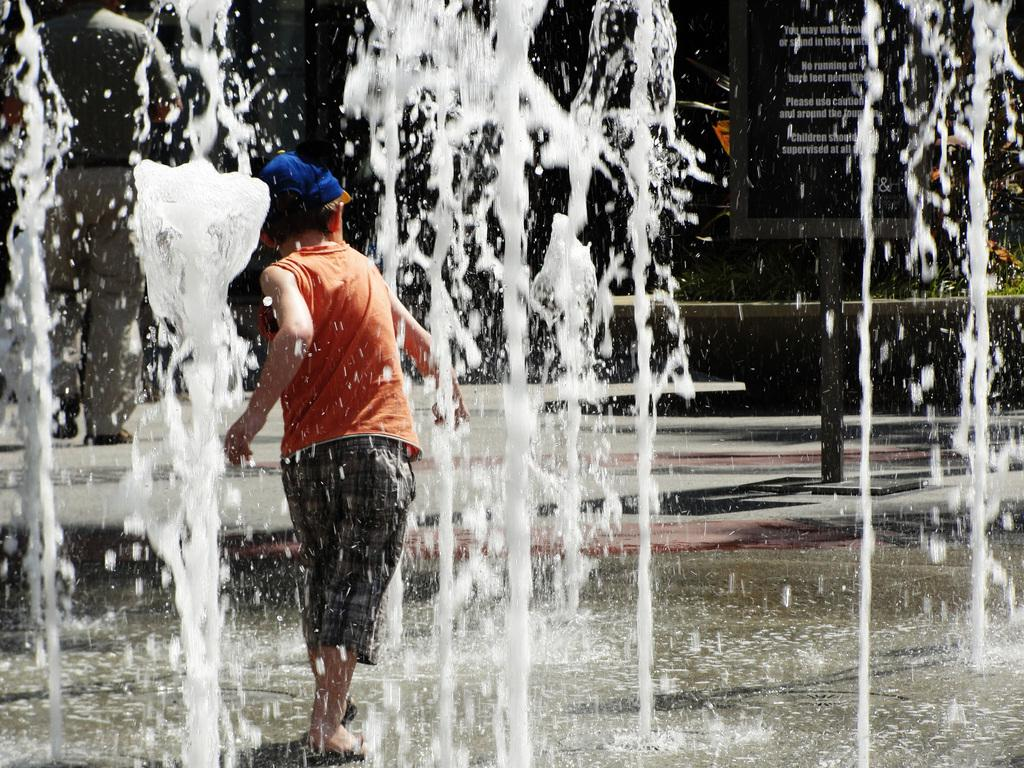What is the main subject of the image? The main subject of the image is a boy. What is the boy doing in the image? The boy is walking in the image. What can be seen in the background of the image? There is a ground water fountain in the image. Why is the boy crying in the image? There is no indication in the image that the boy is crying; he is walking. Who are the boy's friends in the image? There is no mention of friends in the image; it only shows the boy walking. 